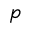<formula> <loc_0><loc_0><loc_500><loc_500>p</formula> 